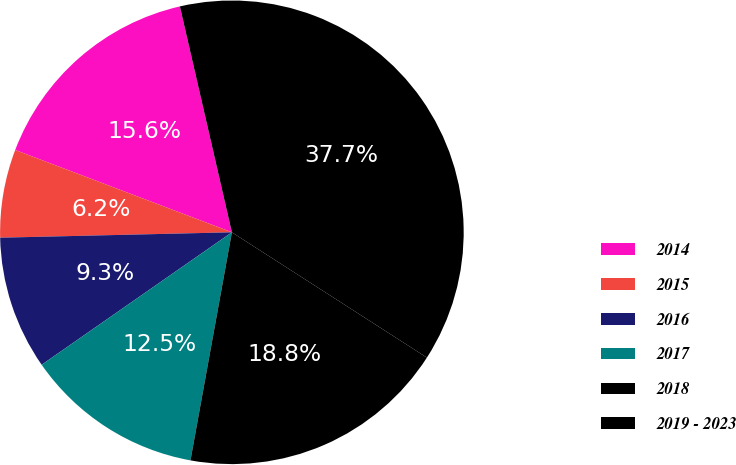Convert chart to OTSL. <chart><loc_0><loc_0><loc_500><loc_500><pie_chart><fcel>2014<fcel>2015<fcel>2016<fcel>2017<fcel>2018<fcel>2019 - 2023<nl><fcel>15.62%<fcel>6.15%<fcel>9.31%<fcel>12.46%<fcel>18.77%<fcel>37.69%<nl></chart> 